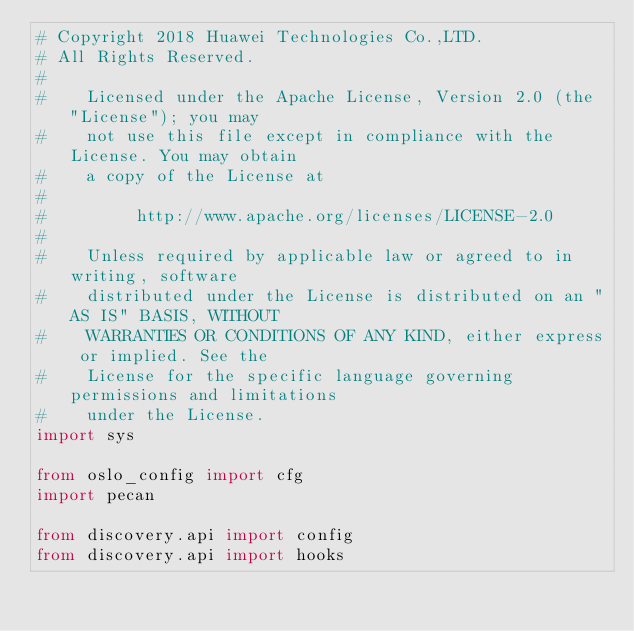Convert code to text. <code><loc_0><loc_0><loc_500><loc_500><_Python_># Copyright 2018 Huawei Technologies Co.,LTD.
# All Rights Reserved.
#
#    Licensed under the Apache License, Version 2.0 (the "License"); you may
#    not use this file except in compliance with the License. You may obtain
#    a copy of the License at
#
#         http://www.apache.org/licenses/LICENSE-2.0
#
#    Unless required by applicable law or agreed to in writing, software
#    distributed under the License is distributed on an "AS IS" BASIS, WITHOUT
#    WARRANTIES OR CONDITIONS OF ANY KIND, either express or implied. See the
#    License for the specific language governing permissions and limitations
#    under the License.
import sys

from oslo_config import cfg
import pecan

from discovery.api import config
from discovery.api import hooks</code> 